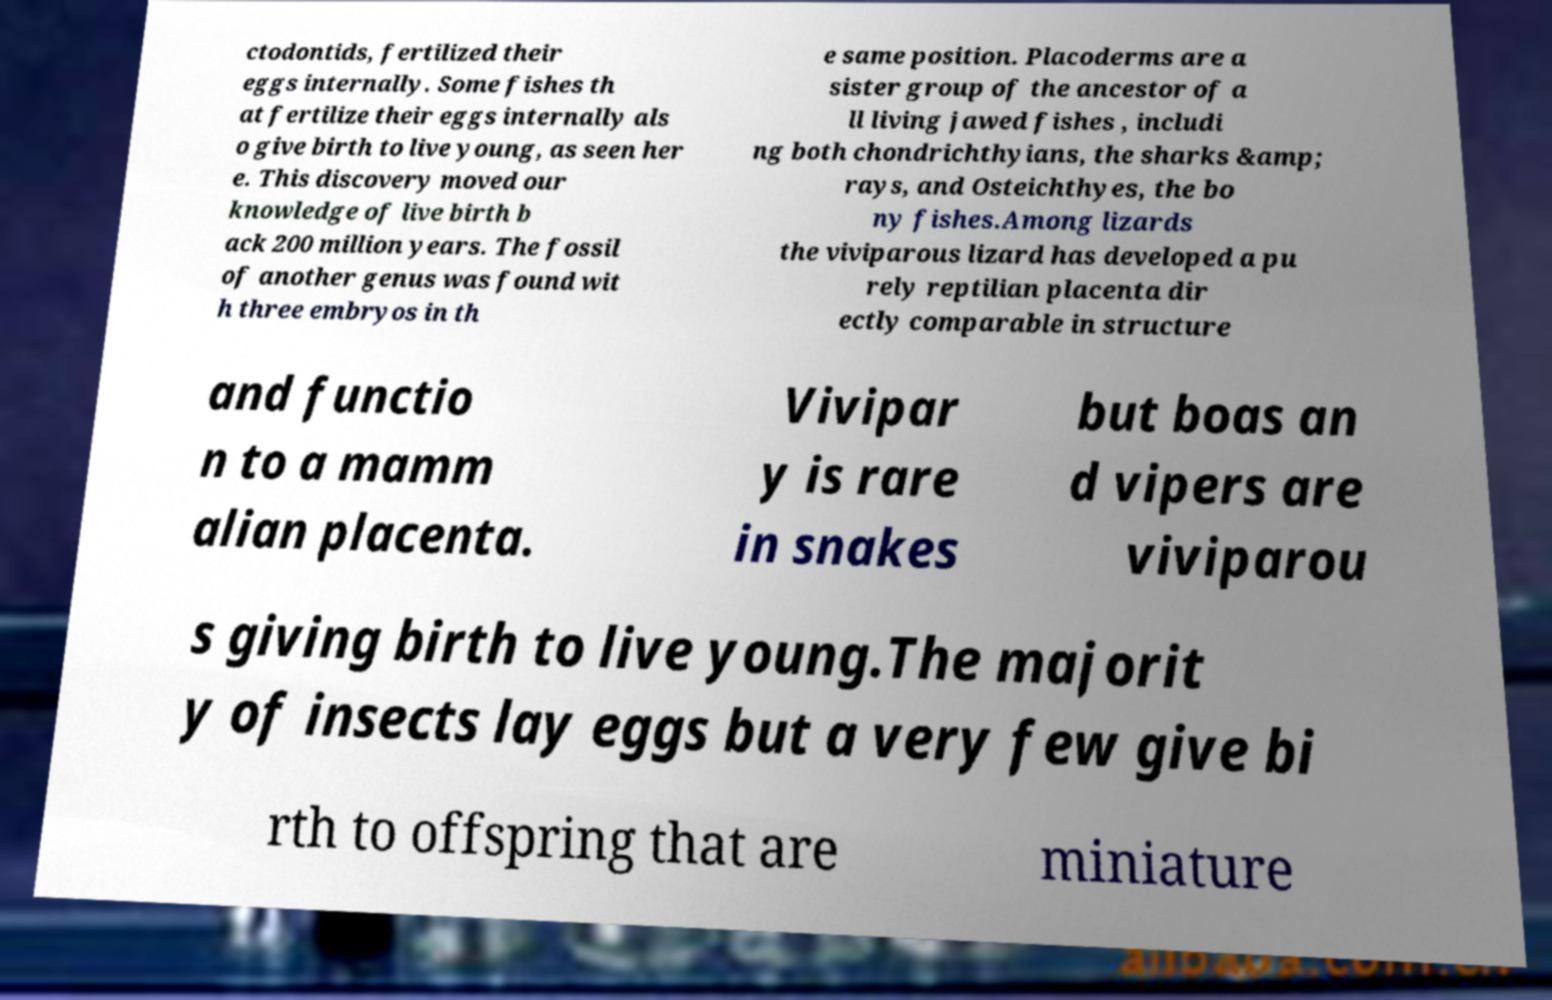For documentation purposes, I need the text within this image transcribed. Could you provide that? ctodontids, fertilized their eggs internally. Some fishes th at fertilize their eggs internally als o give birth to live young, as seen her e. This discovery moved our knowledge of live birth b ack 200 million years. The fossil of another genus was found wit h three embryos in th e same position. Placoderms are a sister group of the ancestor of a ll living jawed fishes , includi ng both chondrichthyians, the sharks &amp; rays, and Osteichthyes, the bo ny fishes.Among lizards the viviparous lizard has developed a pu rely reptilian placenta dir ectly comparable in structure and functio n to a mamm alian placenta. Vivipar y is rare in snakes but boas an d vipers are viviparou s giving birth to live young.The majorit y of insects lay eggs but a very few give bi rth to offspring that are miniature 